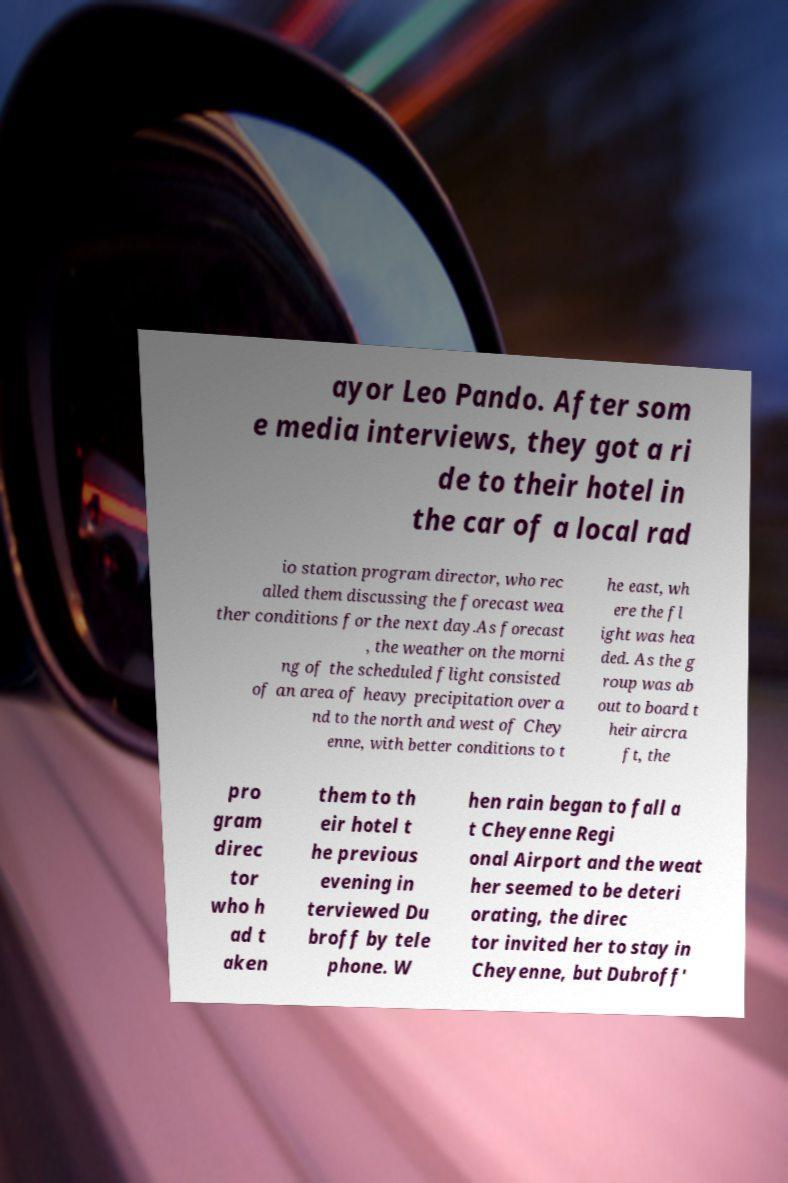What messages or text are displayed in this image? I need them in a readable, typed format. ayor Leo Pando. After som e media interviews, they got a ri de to their hotel in the car of a local rad io station program director, who rec alled them discussing the forecast wea ther conditions for the next day.As forecast , the weather on the morni ng of the scheduled flight consisted of an area of heavy precipitation over a nd to the north and west of Chey enne, with better conditions to t he east, wh ere the fl ight was hea ded. As the g roup was ab out to board t heir aircra ft, the pro gram direc tor who h ad t aken them to th eir hotel t he previous evening in terviewed Du broff by tele phone. W hen rain began to fall a t Cheyenne Regi onal Airport and the weat her seemed to be deteri orating, the direc tor invited her to stay in Cheyenne, but Dubroff' 